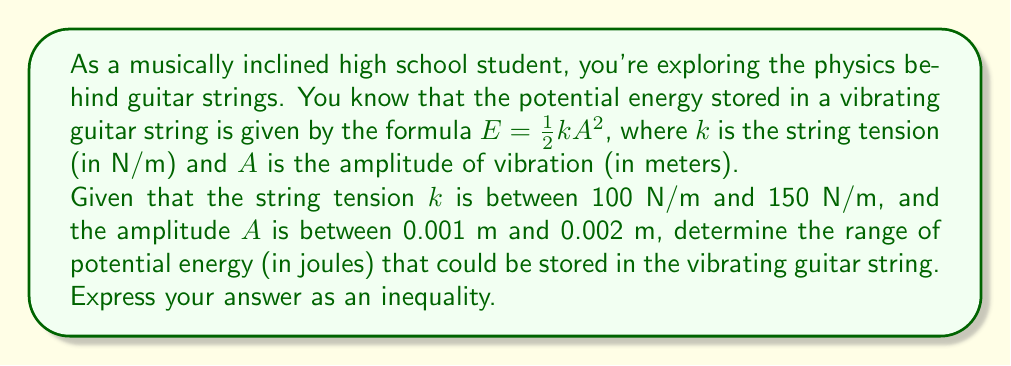Give your solution to this math problem. Let's approach this step-by-step:

1) We're given the formula for potential energy: $E = \frac{1}{2}kA^2$

2) We have these constraints:
   $100 \leq k \leq 150$ (N/m)
   $0.001 \leq A \leq 0.002$ (m)

3) To find the minimum potential energy:
   - Use the minimum values of $k$ and $A$
   $E_{min} = \frac{1}{2} \cdot 100 \cdot (0.001)^2$
   $E_{min} = 50 \cdot 10^{-6}$ J

4) To find the maximum potential energy:
   - Use the maximum values of $k$ and $A$
   $E_{max} = \frac{1}{2} \cdot 150 \cdot (0.002)^2$
   $E_{max} = 300 \cdot 10^{-6}$ J

5) Therefore, the range of potential energy is:
   $50 \cdot 10^{-6} \leq E \leq 300 \cdot 10^{-6}$ J

6) Simplifying by multiplying all parts by $10^6$:
   $50 \leq E \cdot 10^6 \leq 300$ μJ
Answer: $50 \leq E \cdot 10^6 \leq 300$ μJ, where $E$ is in joules. 